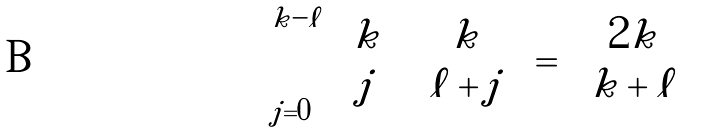Convert formula to latex. <formula><loc_0><loc_0><loc_500><loc_500>\sum _ { j = 0 } ^ { k - \ell } \binom { k } { j } \binom { k } { \ell + j } = \binom { 2 k } { k + \ell }</formula> 